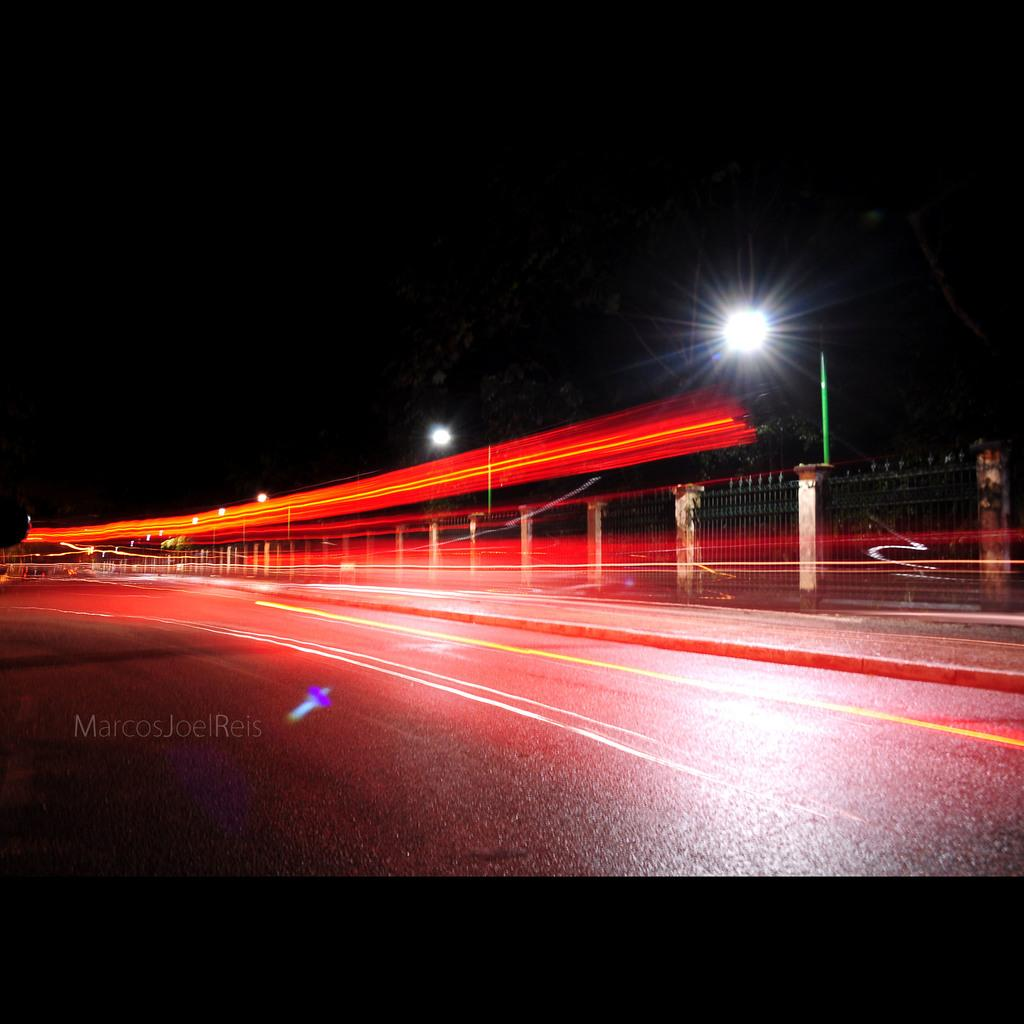What is the main feature of the image? There is a road in the image. What other objects can be seen alongside the road? There are poles and fencing in the image. What is the color of the background in the image? The background of the image is dark. How many passengers are visible in the image? There are no passengers present in the image. What type of group is gathered around the road in the image? There is no group of people gathered around the road in the image. 